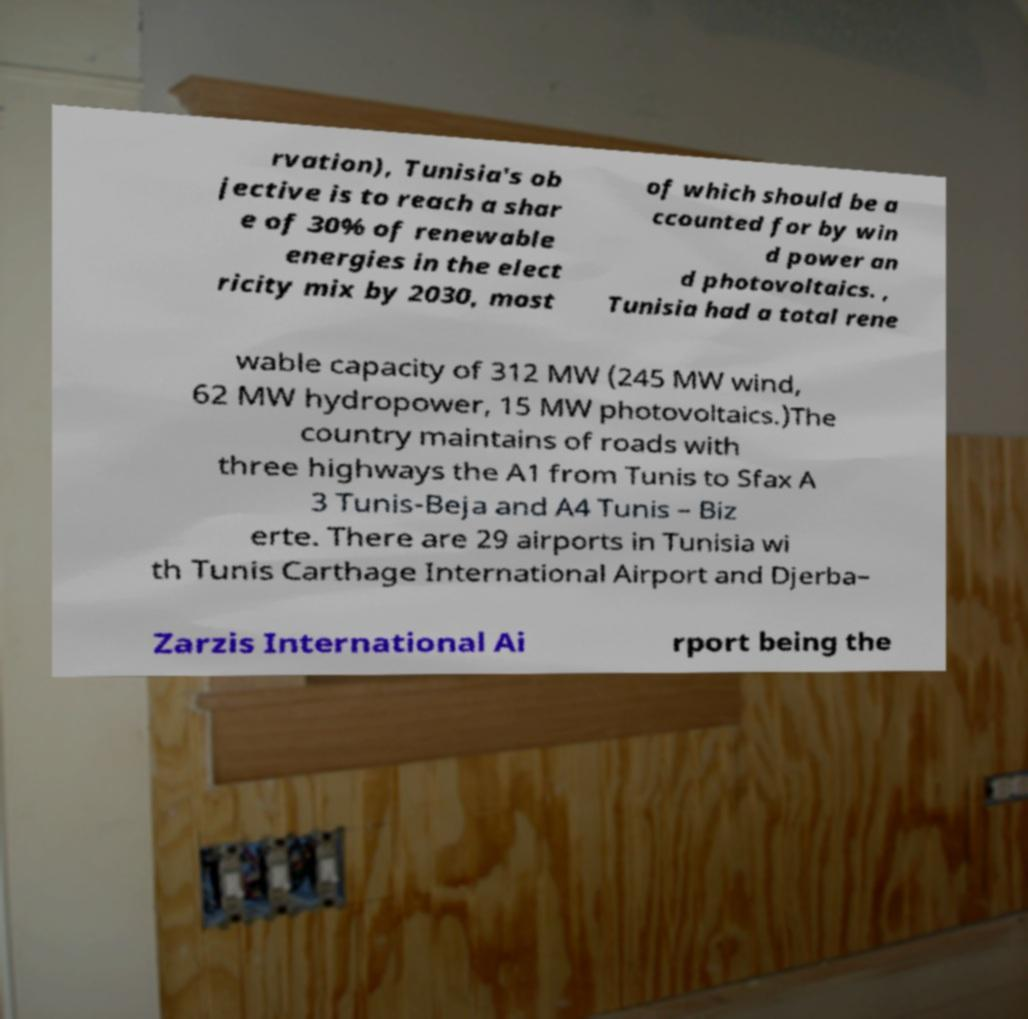What messages or text are displayed in this image? I need them in a readable, typed format. rvation), Tunisia's ob jective is to reach a shar e of 30% of renewable energies in the elect ricity mix by 2030, most of which should be a ccounted for by win d power an d photovoltaics. , Tunisia had a total rene wable capacity of 312 MW (245 MW wind, 62 MW hydropower, 15 MW photovoltaics.)The country maintains of roads with three highways the A1 from Tunis to Sfax A 3 Tunis-Beja and A4 Tunis – Biz erte. There are 29 airports in Tunisia wi th Tunis Carthage International Airport and Djerba– Zarzis International Ai rport being the 